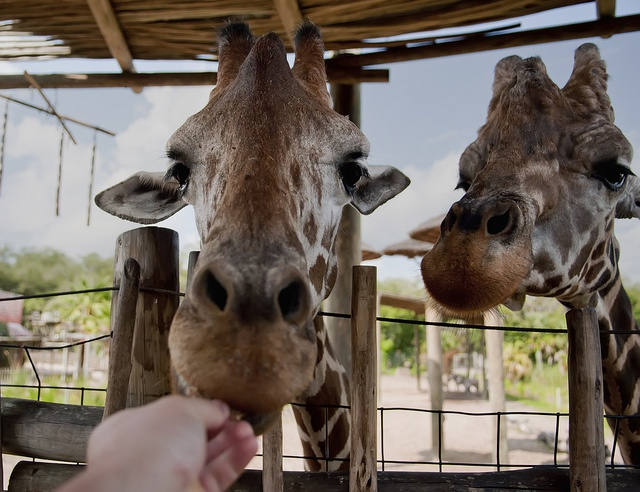Describe the objects in this image and their specific colors. I can see giraffe in maroon, black, and gray tones, giraffe in maroon, black, and gray tones, people in maroon, gray, and brown tones, and car in maroon, darkgray, gray, and lightgray tones in this image. 